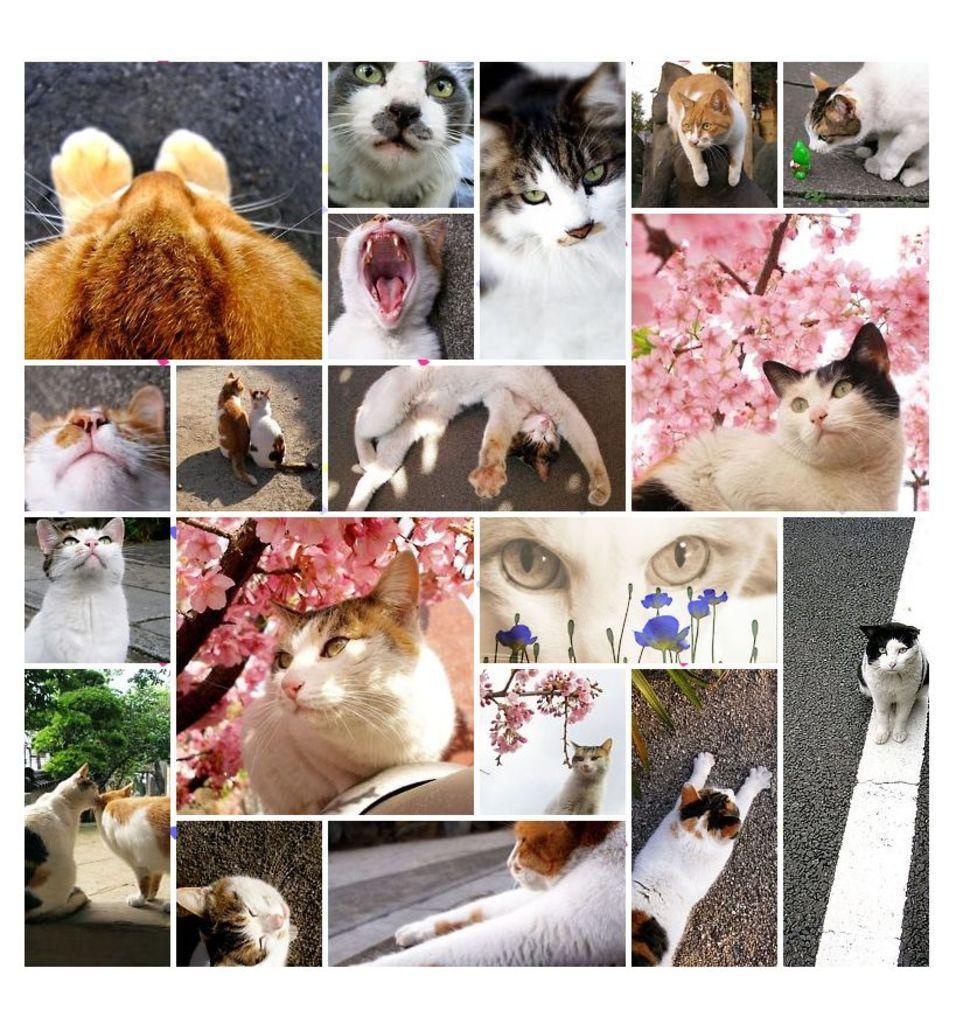Describe this image in one or two sentences. This is an edited collage image. We can see the pictures of cats, flowers, trees and roads. 